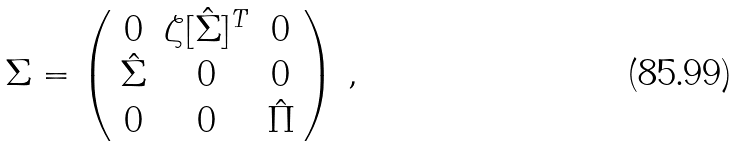<formula> <loc_0><loc_0><loc_500><loc_500>\Sigma = \left ( \begin{array} { c c c } 0 & \zeta [ \hat { \Sigma } ] ^ { T } & 0 \\ \hat { \Sigma } & 0 & 0 \\ 0 & 0 & \hat { \Pi } \end{array} \right ) \, ,</formula> 